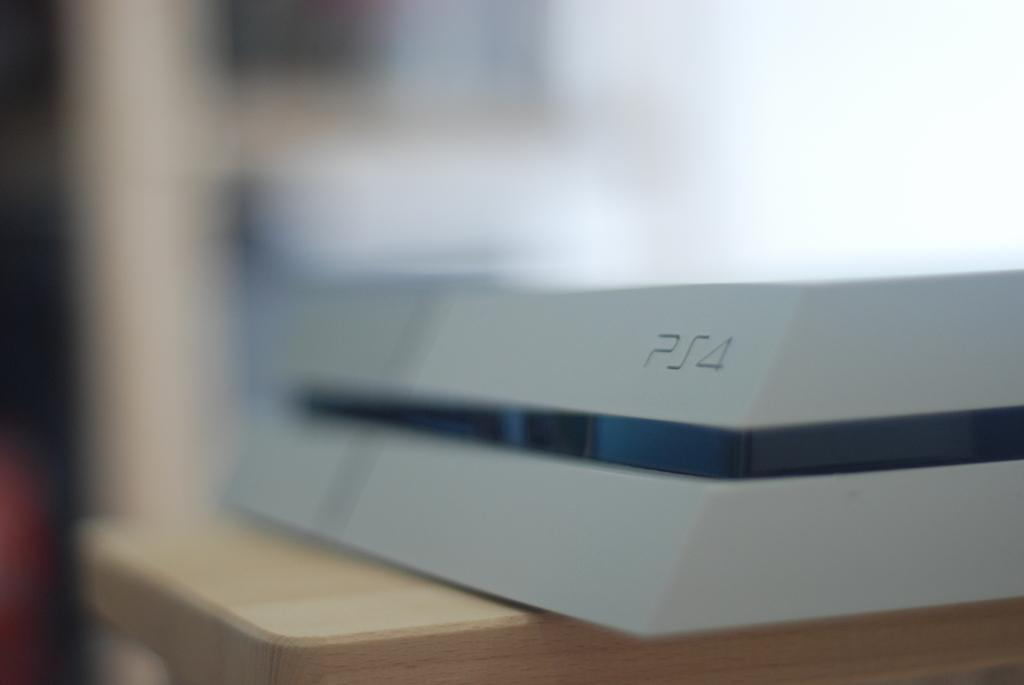<image>
Write a terse but informative summary of the picture. The blue and white box contains a PS4. 